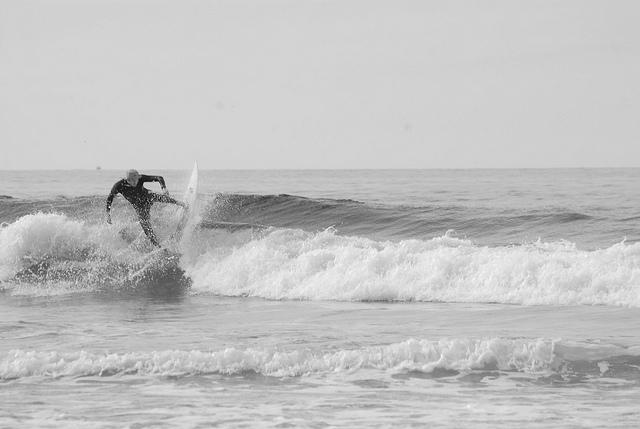In relation to the water, is this person's figure small enough to look like a Chinese character?
Concise answer only. No. What happened to the surfer?
Be succinct. Fell. Is the surfer still on top of the surfboard?
Short answer required. Yes. What gender is the person riding the surfboard?
Write a very short answer. Male. 